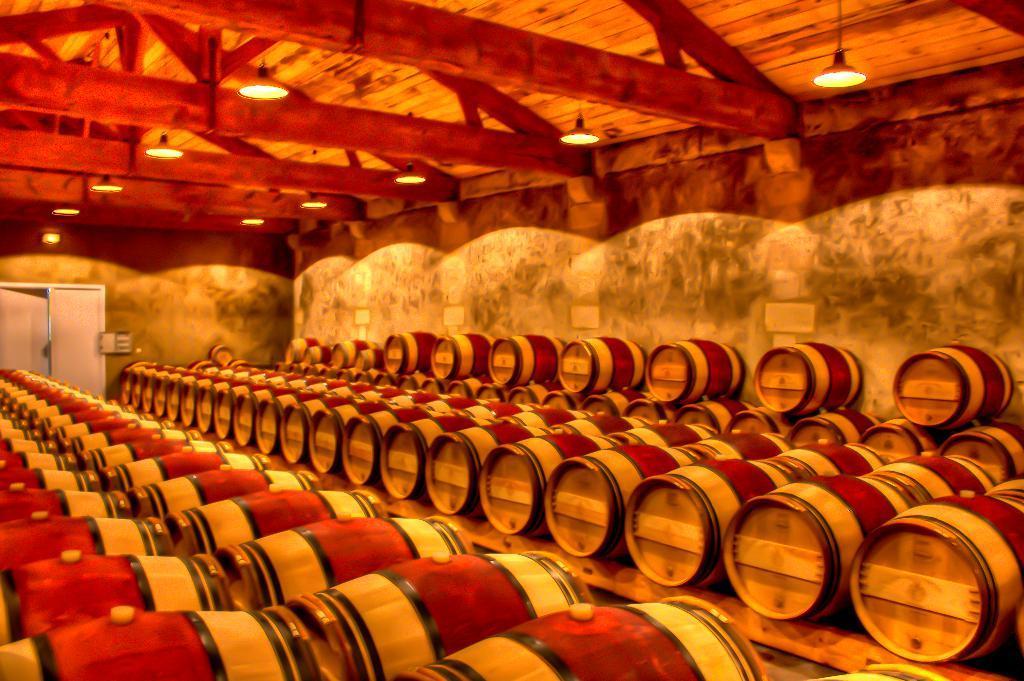How would you summarize this image in a sentence or two? This picture is inside view of a room. We can see come drums are present. In the middle of the image a wall is there. At the top of the image a roof, lights are present. On the left side of the image door is there. 